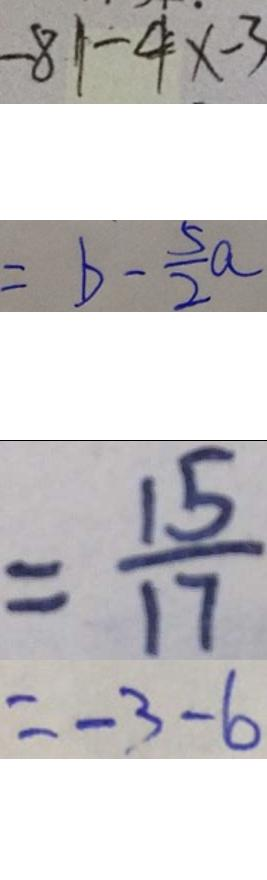<formula> <loc_0><loc_0><loc_500><loc_500>- 8 1 - 4 x - 3 
 = b - \frac { 5 } { 2 } a 
 = \frac { 1 5 } { 1 7 } 
 = - 3 - 6</formula> 